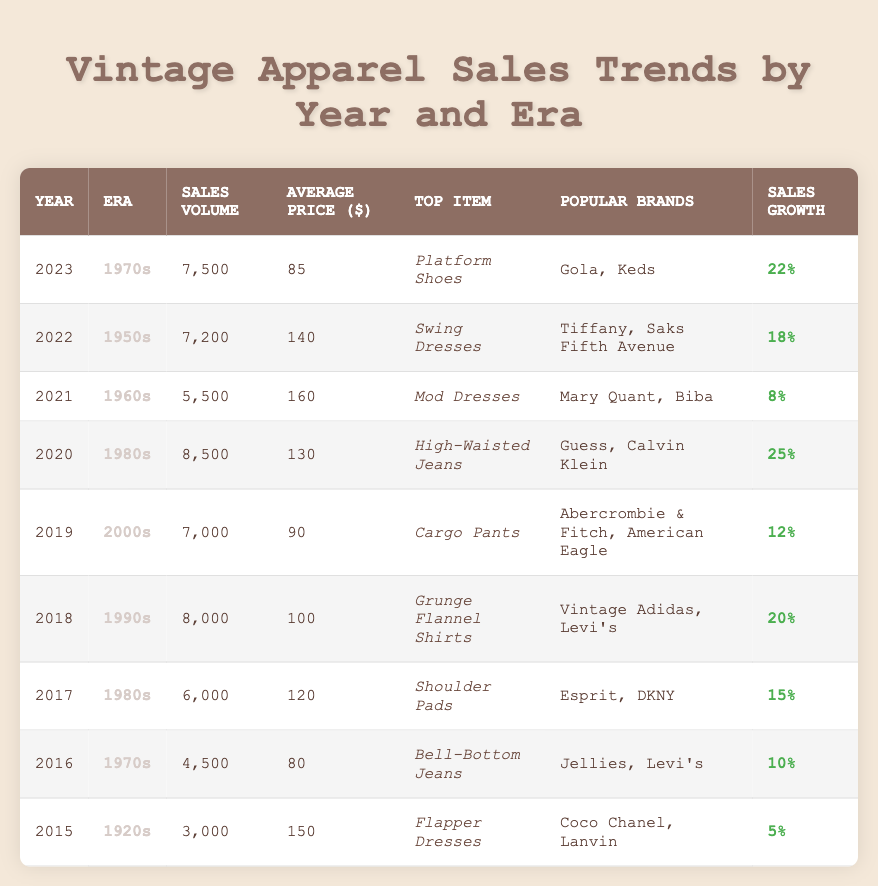What was the sales volume in 2020? The table shows that the sales volume for the year 2020 is 8,500.
Answer: 8,500 Which era had the highest average price in 2021? In 2021, the era with the highest average price is the 1960s, with an average price of $160.
Answer: 1960s What is the top item sold in the 1950s? According to the table, the top item sold in the 1950s is Swing Dresses.
Answer: Swing Dresses How much did sales volume increase from 2015 to 2023? The sales volume in 2015 was 3,000, and in 2023 it was 7,500. The increase is 7,500 - 3,000 = 4,500.
Answer: 4,500 Which year had the lowest sales growth? The table indicates that the lowest sales growth is 5%, which occurred in 2015 for the 1920s.
Answer: 2015 What was the average price of the top item sold in 2018? The average price for the top item, Grunge Flannel Shirts, sold in 2018 is $100.
Answer: $100 Did the sales volume for the 1970s in 2023 exceed the sales volume in 2016? Yes, the sales volume for the 1970s in 2023 was 7,500, which is greater than the 2016 sales volume of 4,500.
Answer: Yes How does the average price of the 1980s in 2020 compare to that in 2017? In 2020, the average price for the 1980s (High-Waisted Jeans) was $130, while in 2017 (Shoulder Pads) it was $120. The 2020 price is higher by $10.
Answer: Higher by $10 Find the year with the highest sales volume overall. The highest sales volume overall in the table is 8,500, which occurred in 2020.
Answer: 2020 If the top item in the 1990s had a sales growth percentage of 20%, what was its sales volume? The sales volume for the 1990s (Grunge Flannel Shirts) in 2018, which has a 20% growth, was 8,000.
Answer: 8,000 Which era saw an increase in sales volume from 2016 to 2023, and by how much? The 1970s saw an increase from 4,500 in 2016 to 7,500 in 2023, which is an increase of 3,000.
Answer: 3,000 